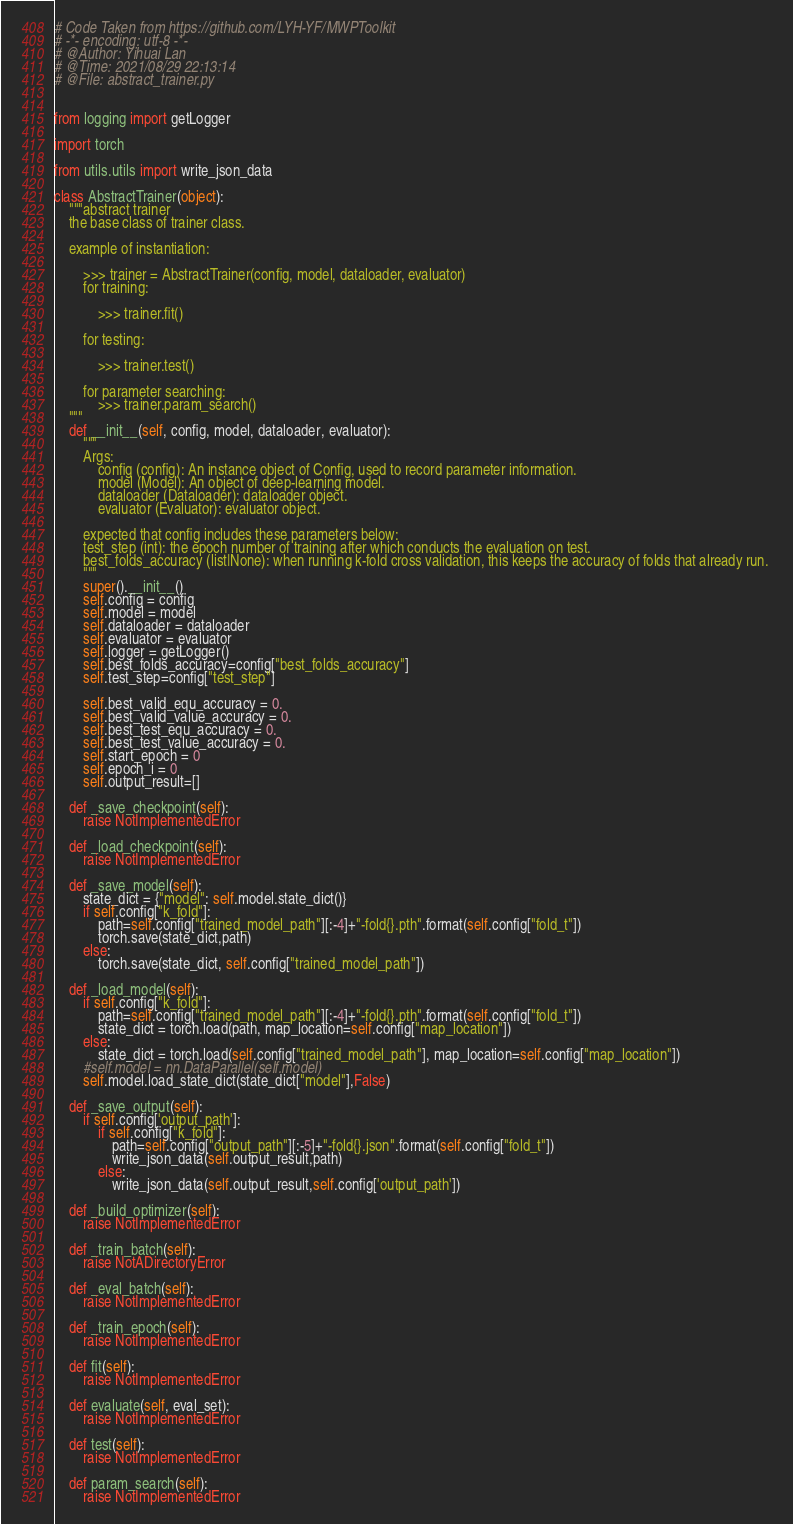Convert code to text. <code><loc_0><loc_0><loc_500><loc_500><_Python_># Code Taken from https://github.com/LYH-YF/MWPToolkit
# -*- encoding: utf-8 -*-
# @Author: Yihuai Lan
# @Time: 2021/08/29 22:13:14
# @File: abstract_trainer.py


from logging import getLogger

import torch

from utils.utils import write_json_data

class AbstractTrainer(object):
    """abstract trainer
    the base class of trainer class.
    
    example of instantiation:
        
        >>> trainer = AbstractTrainer(config, model, dataloader, evaluator)
        for training:
            
            >>> trainer.fit()
        
        for testing:
            
            >>> trainer.test()
        
        for parameter searching:
            >>> trainer.param_search()
    """
    def __init__(self, config, model, dataloader, evaluator):
        """
        Args:
            config (config): An instance object of Config, used to record parameter information.
            model (Model): An object of deep-learning model. 
            dataloader (Dataloader): dataloader object.
            evaluator (Evaluator): evaluator object.
        
        expected that config includes these parameters below:
        test_step (int): the epoch number of training after which conducts the evaluation on test.
        best_folds_accuracy (list|None): when running k-fold cross validation, this keeps the accuracy of folds that already run. 
        """
        super().__init__()
        self.config = config
        self.model = model
        self.dataloader = dataloader
        self.evaluator = evaluator
        self.logger = getLogger()
        self.best_folds_accuracy=config["best_folds_accuracy"]
        self.test_step=config["test_step"]

        self.best_valid_equ_accuracy = 0.
        self.best_valid_value_accuracy = 0.
        self.best_test_equ_accuracy = 0.
        self.best_test_value_accuracy = 0.
        self.start_epoch = 0
        self.epoch_i = 0
        self.output_result=[]

    def _save_checkpoint(self):
        raise NotImplementedError

    def _load_checkpoint(self):
        raise NotImplementedError

    def _save_model(self):
        state_dict = {"model": self.model.state_dict()}
        if self.config["k_fold"]:
            path=self.config["trained_model_path"][:-4]+"-fold{}.pth".format(self.config["fold_t"])
            torch.save(state_dict,path)
        else:
            torch.save(state_dict, self.config["trained_model_path"])

    def _load_model(self):
        if self.config["k_fold"]:
            path=self.config["trained_model_path"][:-4]+"-fold{}.pth".format(self.config["fold_t"])
            state_dict = torch.load(path, map_location=self.config["map_location"])
        else:
            state_dict = torch.load(self.config["trained_model_path"], map_location=self.config["map_location"])
        #self.model = nn.DataParallel(self.model)
        self.model.load_state_dict(state_dict["model"],False)
    
    def _save_output(self):
        if self.config['output_path']:
            if self.config["k_fold"]:
                path=self.config["output_path"][:-5]+"-fold{}.json".format(self.config["fold_t"])
                write_json_data(self.output_result,path)
            else:
                write_json_data(self.output_result,self.config['output_path'])

    def _build_optimizer(self):
        raise NotImplementedError

    def _train_batch(self):
        raise NotADirectoryError

    def _eval_batch(self):
        raise NotImplementedError

    def _train_epoch(self):
        raise NotImplementedError

    def fit(self):
        raise NotImplementedError

    def evaluate(self, eval_set):
        raise NotImplementedError

    def test(self):
        raise NotImplementedError

    def param_search(self):
        raise NotImplementedError</code> 